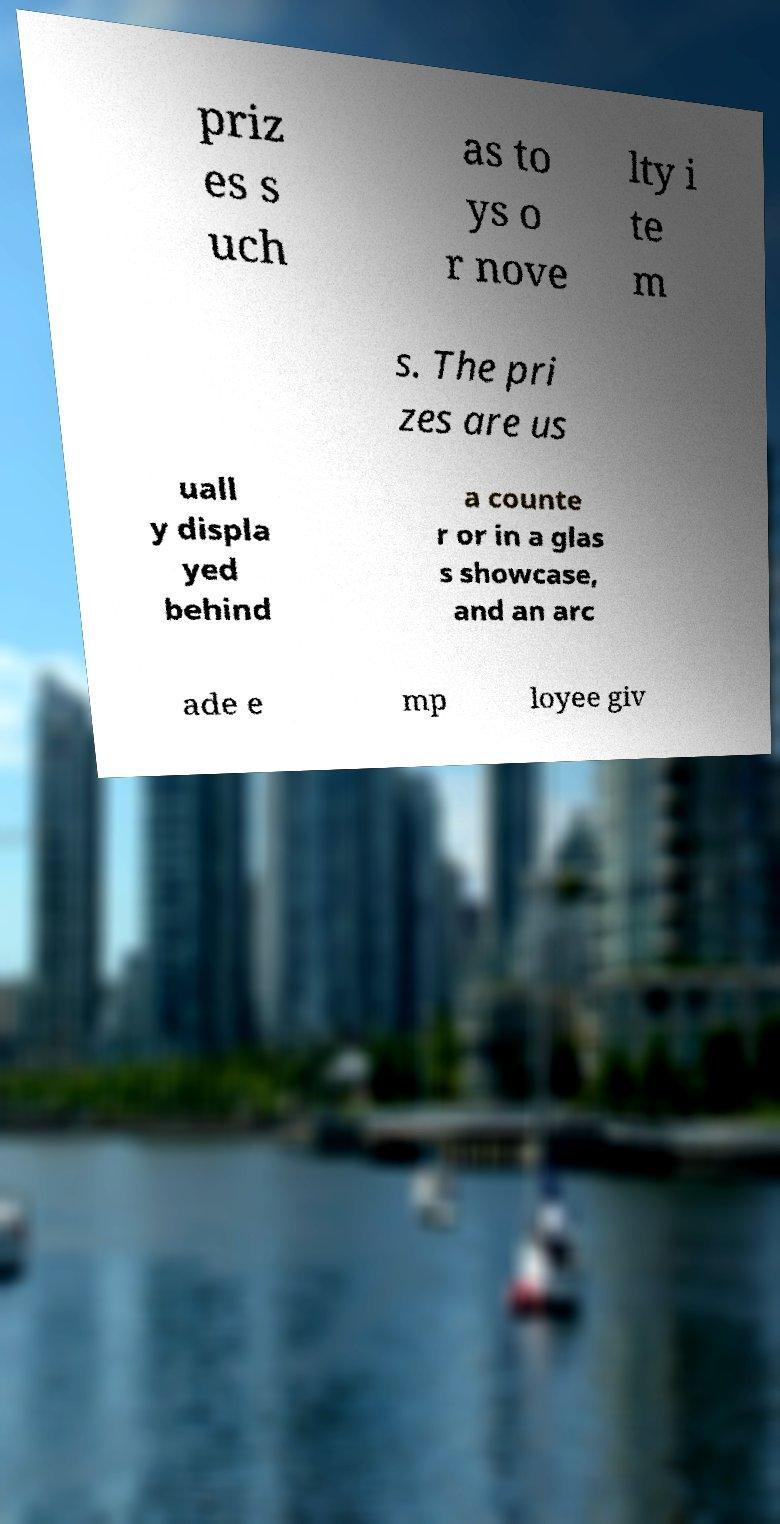What messages or text are displayed in this image? I need them in a readable, typed format. priz es s uch as to ys o r nove lty i te m s. The pri zes are us uall y displa yed behind a counte r or in a glas s showcase, and an arc ade e mp loyee giv 